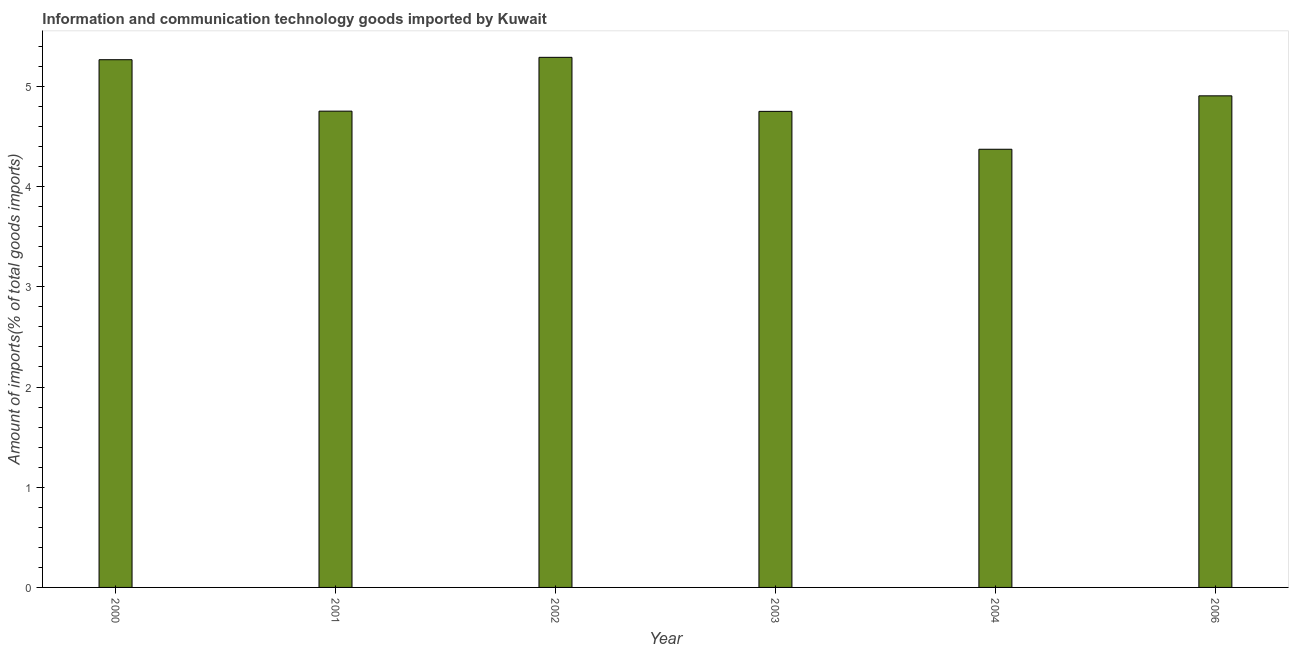Does the graph contain any zero values?
Provide a short and direct response. No. What is the title of the graph?
Provide a short and direct response. Information and communication technology goods imported by Kuwait. What is the label or title of the Y-axis?
Offer a terse response. Amount of imports(% of total goods imports). What is the amount of ict goods imports in 2002?
Offer a very short reply. 5.29. Across all years, what is the maximum amount of ict goods imports?
Provide a succinct answer. 5.29. Across all years, what is the minimum amount of ict goods imports?
Your answer should be very brief. 4.37. In which year was the amount of ict goods imports maximum?
Your answer should be very brief. 2002. In which year was the amount of ict goods imports minimum?
Make the answer very short. 2004. What is the sum of the amount of ict goods imports?
Offer a terse response. 29.34. What is the difference between the amount of ict goods imports in 2000 and 2006?
Your answer should be very brief. 0.36. What is the average amount of ict goods imports per year?
Ensure brevity in your answer.  4.89. What is the median amount of ict goods imports?
Your response must be concise. 4.83. In how many years, is the amount of ict goods imports greater than 4.6 %?
Make the answer very short. 5. Is the difference between the amount of ict goods imports in 2002 and 2006 greater than the difference between any two years?
Provide a short and direct response. No. What is the difference between the highest and the second highest amount of ict goods imports?
Offer a very short reply. 0.02. Is the sum of the amount of ict goods imports in 2002 and 2004 greater than the maximum amount of ict goods imports across all years?
Offer a very short reply. Yes. In how many years, is the amount of ict goods imports greater than the average amount of ict goods imports taken over all years?
Provide a succinct answer. 3. Are all the bars in the graph horizontal?
Offer a terse response. No. Are the values on the major ticks of Y-axis written in scientific E-notation?
Your answer should be very brief. No. What is the Amount of imports(% of total goods imports) of 2000?
Offer a terse response. 5.27. What is the Amount of imports(% of total goods imports) of 2001?
Provide a short and direct response. 4.75. What is the Amount of imports(% of total goods imports) of 2002?
Your response must be concise. 5.29. What is the Amount of imports(% of total goods imports) in 2003?
Ensure brevity in your answer.  4.75. What is the Amount of imports(% of total goods imports) of 2004?
Keep it short and to the point. 4.37. What is the Amount of imports(% of total goods imports) of 2006?
Your response must be concise. 4.91. What is the difference between the Amount of imports(% of total goods imports) in 2000 and 2001?
Offer a very short reply. 0.51. What is the difference between the Amount of imports(% of total goods imports) in 2000 and 2002?
Ensure brevity in your answer.  -0.02. What is the difference between the Amount of imports(% of total goods imports) in 2000 and 2003?
Your answer should be very brief. 0.52. What is the difference between the Amount of imports(% of total goods imports) in 2000 and 2004?
Your response must be concise. 0.89. What is the difference between the Amount of imports(% of total goods imports) in 2000 and 2006?
Provide a short and direct response. 0.36. What is the difference between the Amount of imports(% of total goods imports) in 2001 and 2002?
Ensure brevity in your answer.  -0.54. What is the difference between the Amount of imports(% of total goods imports) in 2001 and 2003?
Your answer should be compact. 0. What is the difference between the Amount of imports(% of total goods imports) in 2001 and 2004?
Keep it short and to the point. 0.38. What is the difference between the Amount of imports(% of total goods imports) in 2001 and 2006?
Your response must be concise. -0.15. What is the difference between the Amount of imports(% of total goods imports) in 2002 and 2003?
Provide a succinct answer. 0.54. What is the difference between the Amount of imports(% of total goods imports) in 2002 and 2004?
Offer a very short reply. 0.92. What is the difference between the Amount of imports(% of total goods imports) in 2002 and 2006?
Provide a succinct answer. 0.38. What is the difference between the Amount of imports(% of total goods imports) in 2003 and 2004?
Keep it short and to the point. 0.38. What is the difference between the Amount of imports(% of total goods imports) in 2003 and 2006?
Your answer should be compact. -0.15. What is the difference between the Amount of imports(% of total goods imports) in 2004 and 2006?
Give a very brief answer. -0.53. What is the ratio of the Amount of imports(% of total goods imports) in 2000 to that in 2001?
Offer a very short reply. 1.11. What is the ratio of the Amount of imports(% of total goods imports) in 2000 to that in 2002?
Provide a succinct answer. 0.99. What is the ratio of the Amount of imports(% of total goods imports) in 2000 to that in 2003?
Provide a succinct answer. 1.11. What is the ratio of the Amount of imports(% of total goods imports) in 2000 to that in 2004?
Offer a very short reply. 1.2. What is the ratio of the Amount of imports(% of total goods imports) in 2000 to that in 2006?
Offer a terse response. 1.07. What is the ratio of the Amount of imports(% of total goods imports) in 2001 to that in 2002?
Give a very brief answer. 0.9. What is the ratio of the Amount of imports(% of total goods imports) in 2001 to that in 2003?
Your answer should be compact. 1. What is the ratio of the Amount of imports(% of total goods imports) in 2001 to that in 2004?
Provide a succinct answer. 1.09. What is the ratio of the Amount of imports(% of total goods imports) in 2002 to that in 2003?
Offer a very short reply. 1.11. What is the ratio of the Amount of imports(% of total goods imports) in 2002 to that in 2004?
Give a very brief answer. 1.21. What is the ratio of the Amount of imports(% of total goods imports) in 2002 to that in 2006?
Give a very brief answer. 1.08. What is the ratio of the Amount of imports(% of total goods imports) in 2003 to that in 2004?
Offer a very short reply. 1.09. What is the ratio of the Amount of imports(% of total goods imports) in 2003 to that in 2006?
Ensure brevity in your answer.  0.97. What is the ratio of the Amount of imports(% of total goods imports) in 2004 to that in 2006?
Your answer should be compact. 0.89. 